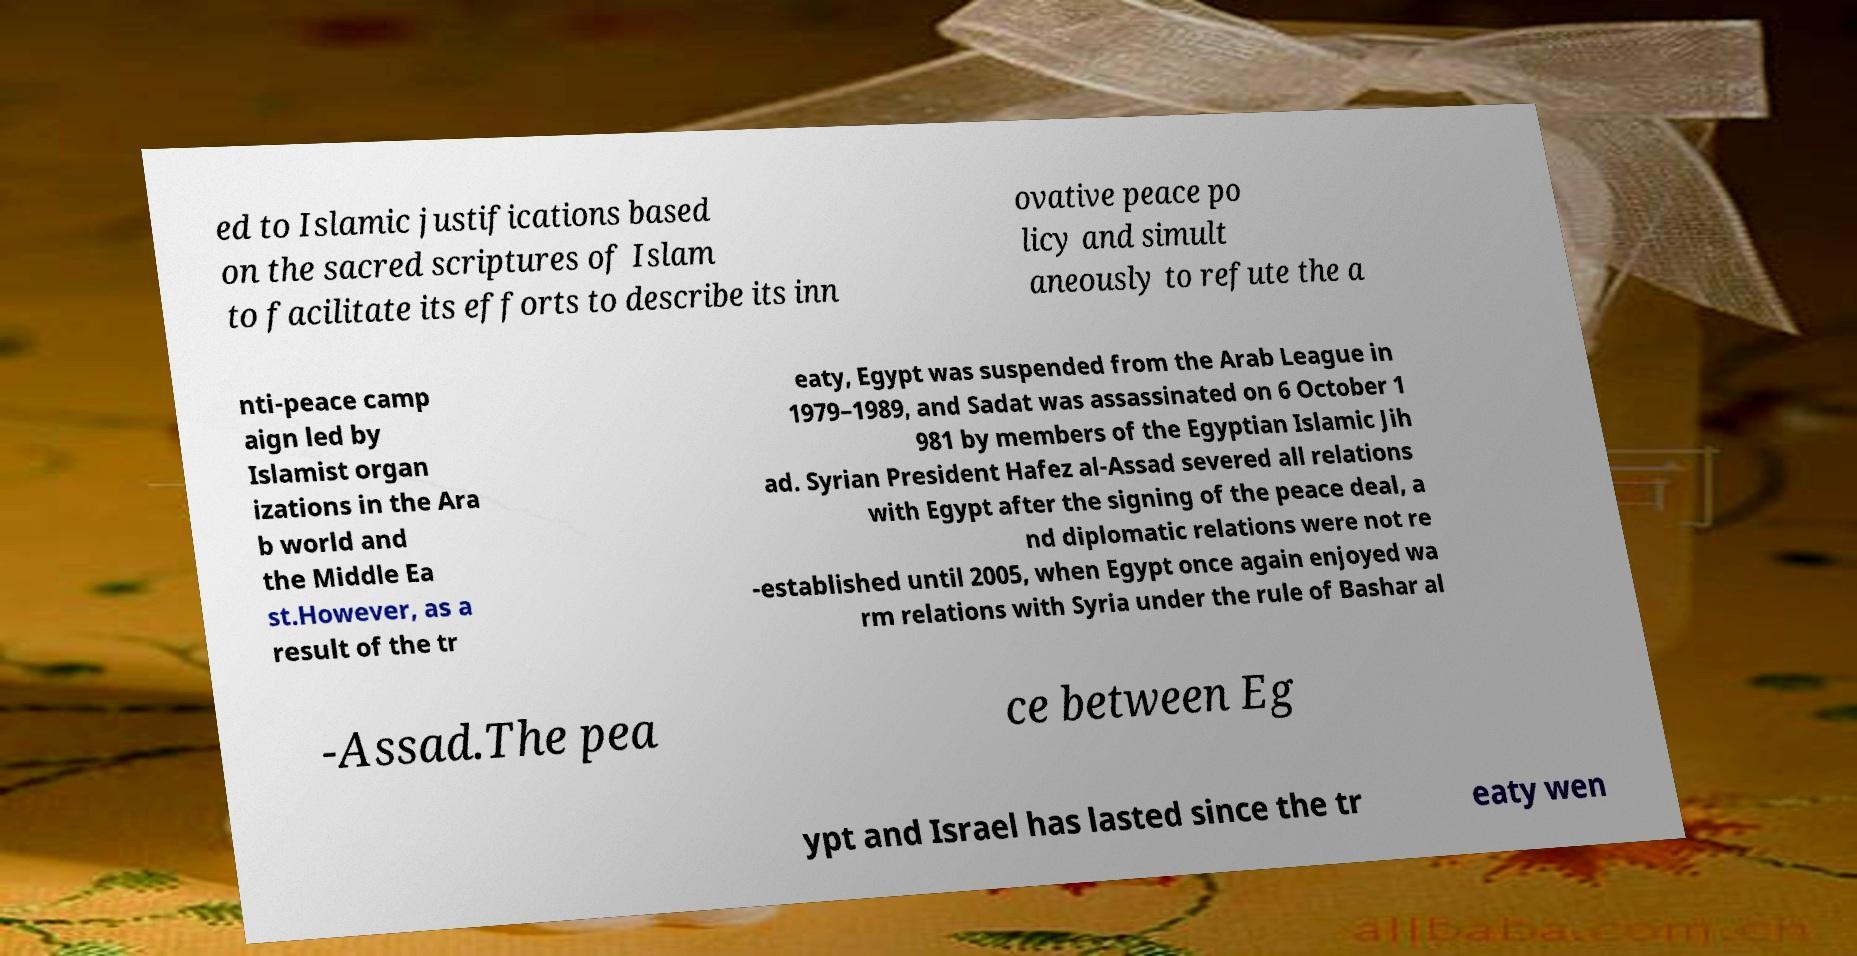For documentation purposes, I need the text within this image transcribed. Could you provide that? ed to Islamic justifications based on the sacred scriptures of Islam to facilitate its efforts to describe its inn ovative peace po licy and simult aneously to refute the a nti-peace camp aign led by Islamist organ izations in the Ara b world and the Middle Ea st.However, as a result of the tr eaty, Egypt was suspended from the Arab League in 1979–1989, and Sadat was assassinated on 6 October 1 981 by members of the Egyptian Islamic Jih ad. Syrian President Hafez al-Assad severed all relations with Egypt after the signing of the peace deal, a nd diplomatic relations were not re -established until 2005, when Egypt once again enjoyed wa rm relations with Syria under the rule of Bashar al -Assad.The pea ce between Eg ypt and Israel has lasted since the tr eaty wen 